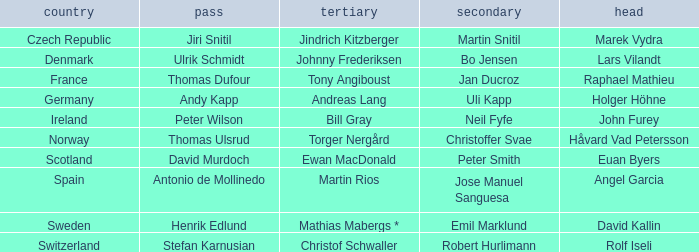Which Third has a Nation of scotland? Ewan MacDonald. 